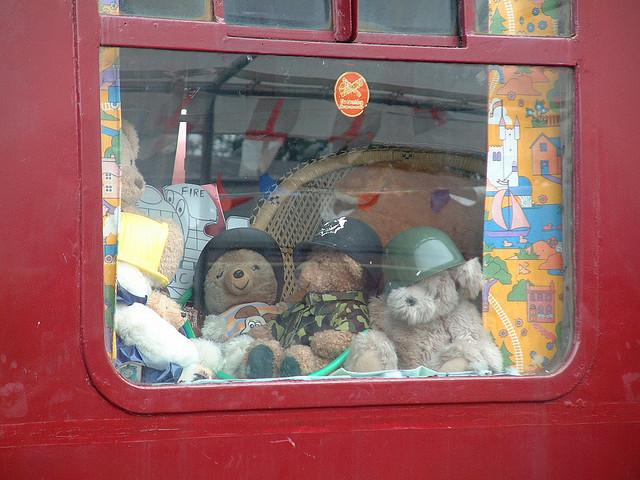What are the toys in the window called? teddy bears 